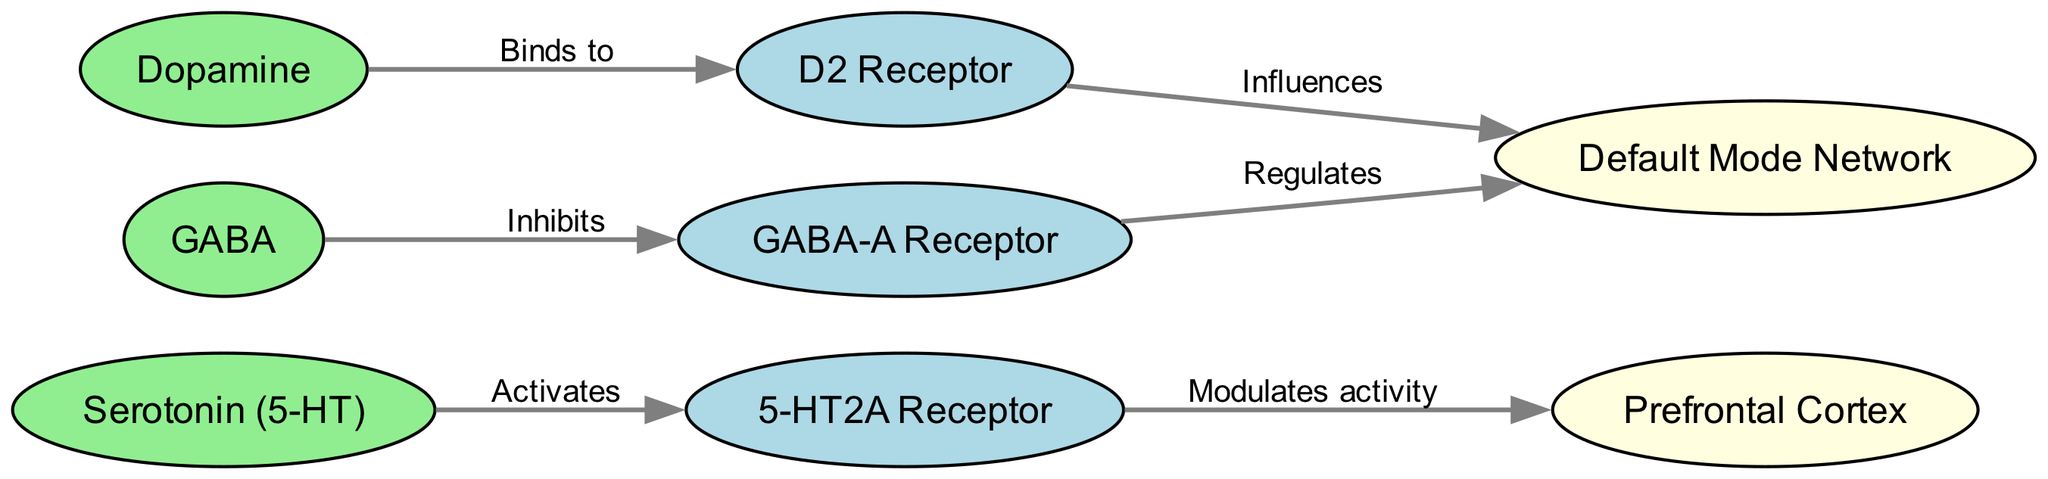What neurotransmitter activates the 5-HT2A receptor? The diagram indicates that Serotonin (5-HT) is the neurotransmitter that activates the 5-HT2A receptor, as shown by the directed edge labeled "Activates" from the serotonin node to the receptor node.
Answer: Serotonin (5-HT) Which receptor does Dopamine bind to? According to the diagram, Dopamine has a directed edge labeled "Binds to" leading to the D2 receptor, indicating that Dopamine specifically binds to this receptor.
Answer: D2 Receptor How many nodes are present in the diagram? By counting the total nodes represented in the diagram, we find there are eight nodes in total: Serotonin, 5-HT2A Receptor, Dopamine, D2 Receptor, GABA, GABA-A Receptor, Prefrontal Cortex, and Default Mode Network.
Answer: Eight What is the relationship between GABA and the GABA-A receptor? The diagram illustrates that GABA inhibits the GABA-A receptor, as represented by the directed edge labeled "Inhibits" connecting the GABA node to the GABA-A receptor node.
Answer: Inhibits Which area of the brain is modulated by the 5-HT2A receptor? From the diagram, we see an edge from the 5-HT2A receptor to the Prefrontal Cortex indicating that this area is modulated by the receptor's activity.
Answer: Prefrontal Cortex How does the D2 receptor influence the Default Mode Network? The diagram shows that the D2 receptor influences the Default Mode Network, reflected by a directed edge with the label "Influences," linking the D2 receptor to the Default Mode Network.
Answer: Influences How many distinct types of receptors are represented in the diagram? On examining the nodes, we can identify three distinct types of receptors: 5-HT2A Receptor, D2 Receptor, and GABA-A Receptor, thus yielding a count of three types of receptors in total.
Answer: Three Which neurotransmitter regulates the Default Mode Network? The diagram indicates that both the GABA-A receptor and the D2 receptor have directed edges leading to the Default Mode Network, signifying their regulatory roles on it. Specifically, GABA-A receptor is mentioned as regulating the Default Mode Network.
Answer: GABA-A Receptor What effect does GABA have on the Default Mode Network? In looking at the connections, we see that the GABA-A receptor regulates the Default Mode Network as depicted by the directed edge labeled "Regulates," implying that GABA has an inhibiting effect through this receptor on the Default Mode Network.
Answer: Regulates 